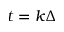Convert formula to latex. <formula><loc_0><loc_0><loc_500><loc_500>t = k \Delta</formula> 